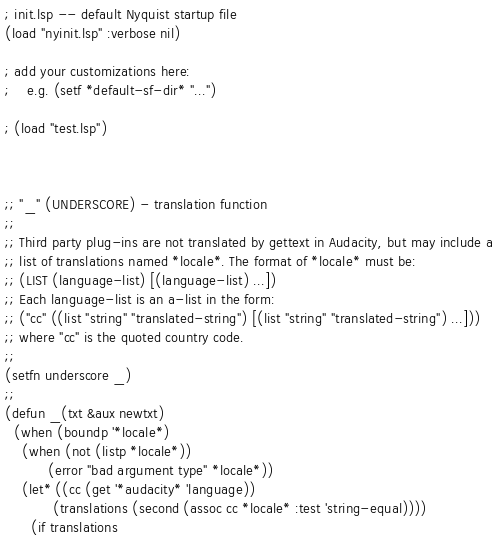<code> <loc_0><loc_0><loc_500><loc_500><_Lisp_>; init.lsp -- default Nyquist startup file
(load "nyinit.lsp" :verbose nil)

; add your customizations here:
;    e.g. (setf *default-sf-dir* "...")

; (load "test.lsp")



;; "_" (UNDERSCORE) - translation function
;;
;; Third party plug-ins are not translated by gettext in Audacity, but may include a
;; list of translations named *locale*. The format of *locale* must be:
;; (LIST (language-list) [(language-list) ...]) 
;; Each language-list is an a-list in the form:
;; ("cc" ((list "string" "translated-string") [(list "string" "translated-string") ...]))
;; where "cc" is the quoted country code.
;;
(setfn underscore _)
;;
(defun _(txt &aux newtxt)
  (when (boundp '*locale*)
    (when (not (listp *locale*))
          (error "bad argument type" *locale*))
    (let* ((cc (get '*audacity* 'language))
           (translations (second (assoc cc *locale* :test 'string-equal))))
      (if translations</code> 